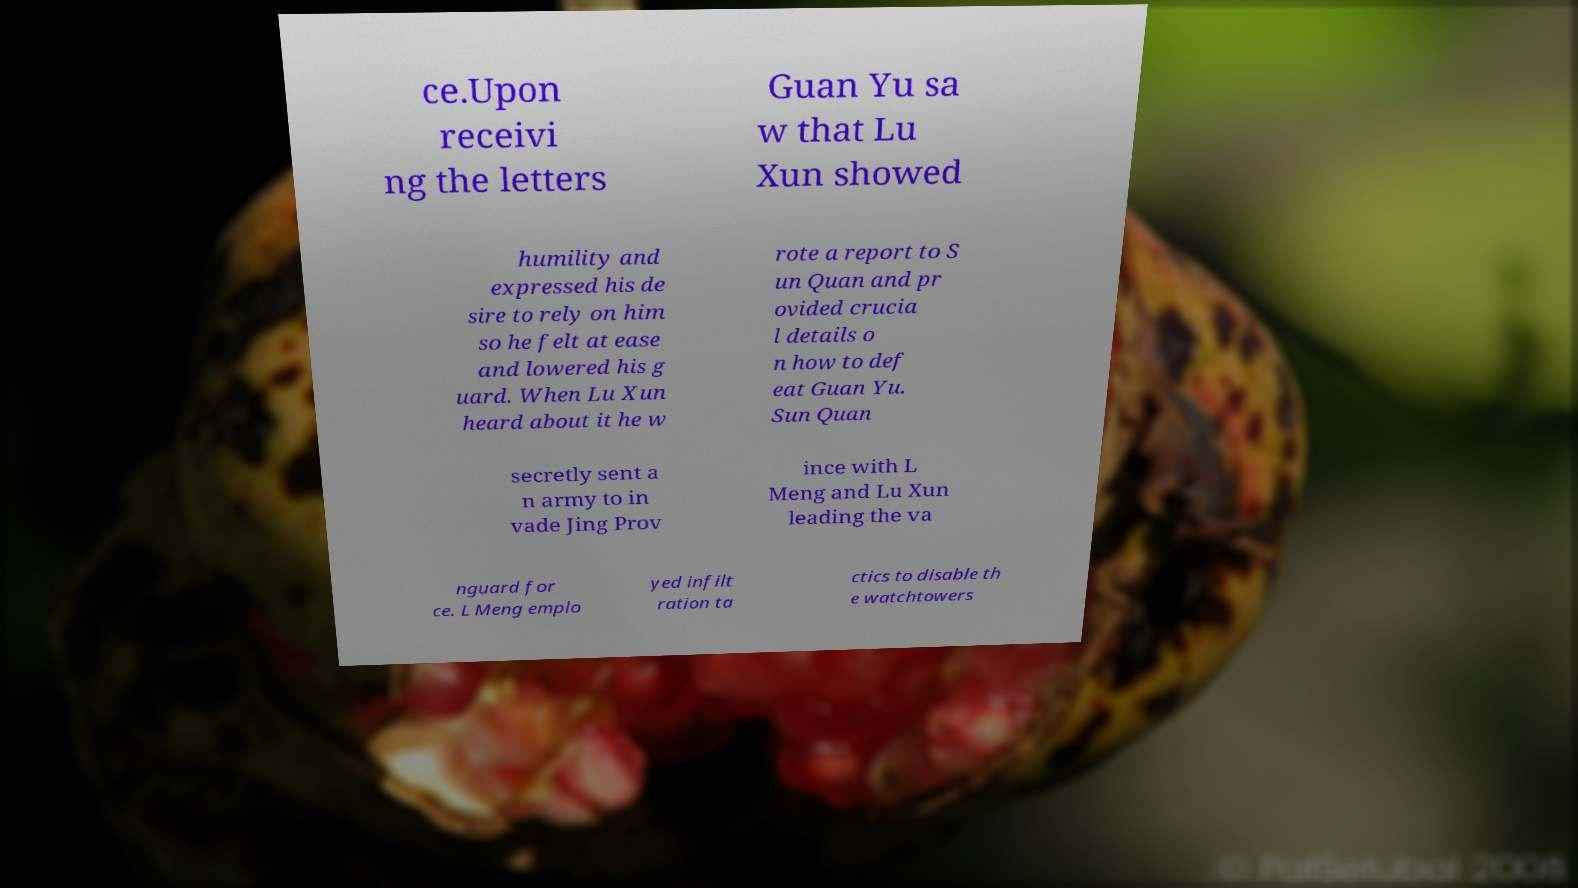Can you read and provide the text displayed in the image?This photo seems to have some interesting text. Can you extract and type it out for me? ce.Upon receivi ng the letters Guan Yu sa w that Lu Xun showed humility and expressed his de sire to rely on him so he felt at ease and lowered his g uard. When Lu Xun heard about it he w rote a report to S un Quan and pr ovided crucia l details o n how to def eat Guan Yu. Sun Quan secretly sent a n army to in vade Jing Prov ince with L Meng and Lu Xun leading the va nguard for ce. L Meng emplo yed infilt ration ta ctics to disable th e watchtowers 